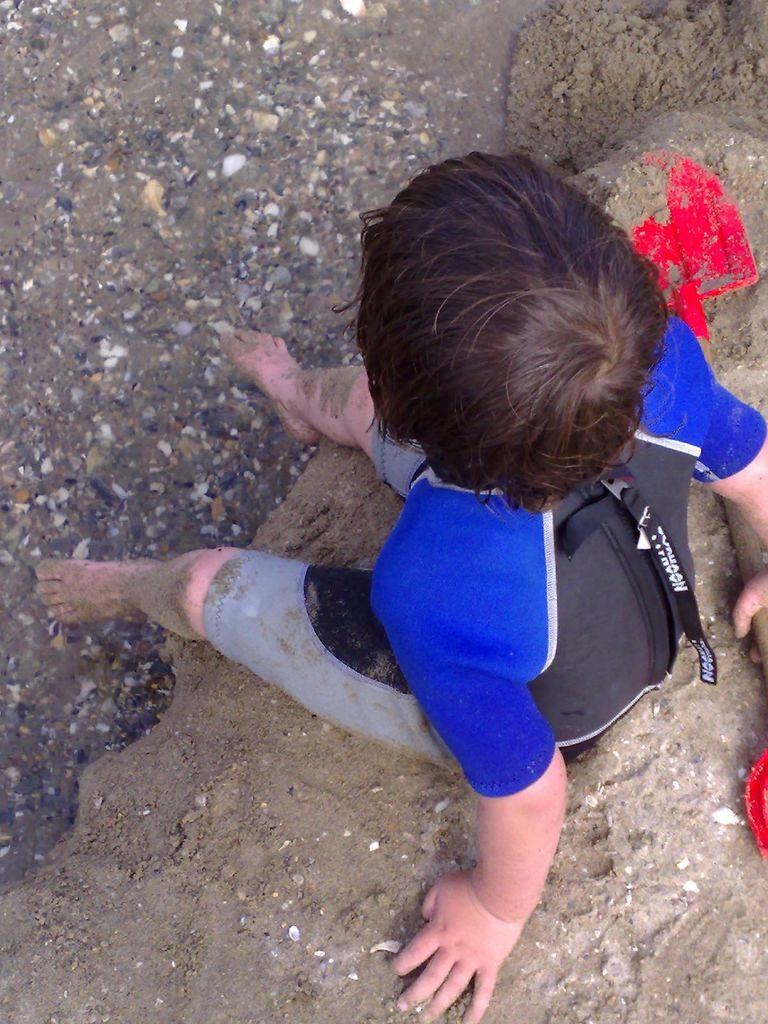What is the main subject of the image? The main subject of the image is a kid. What is the kid doing in the image? The kid is sitting on the ground. What type of clothing is the kid wearing? The kid is wearing a swimsuit. What expertise does the kid have in the image? There is no indication of any expertise in the image; it simply shows a kid sitting on the ground wearing a swimsuit. --- Facts: 1. There is a car in the image. 2. The car is red. 3. There are people inside the car. 4. The car has four wheels. Absurd Topics: unicorn, rainbow, clouds Conversation: What is the main subject in the image? The main subject in the image is a car. Can you describe the car in the image? Yes, the car in the image is red. Are there any people inside the car in the image? Yes, there are people inside the car in the image. How many wheels does the car have in the image? The car in the image has four wheels. Reasoning: Let's think step by step in order to produce the conversation. We start by identifying the main subject of the image, which is a car. Next, we describe specific features of the car, such as its color (red) and the number of wheels it has (four wheels)). Then, we observe the actions of the people inside the car, noting that they are present in the image. Finally, we ensure that the language is simple and clear. Absurd Question/Answer: Can you see a unicorn in the image? No, there is no unicorn present in the image. 